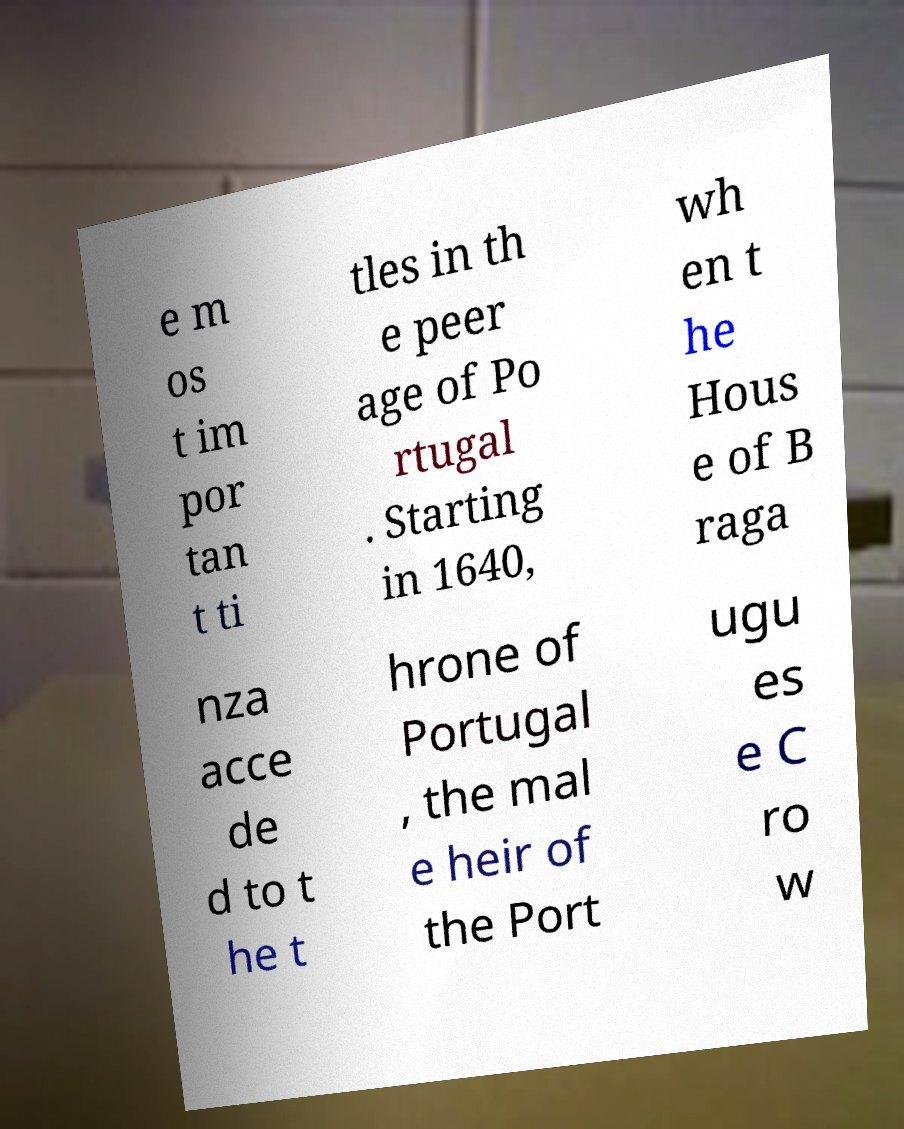There's text embedded in this image that I need extracted. Can you transcribe it verbatim? e m os t im por tan t ti tles in th e peer age of Po rtugal . Starting in 1640, wh en t he Hous e of B raga nza acce de d to t he t hrone of Portugal , the mal e heir of the Port ugu es e C ro w 